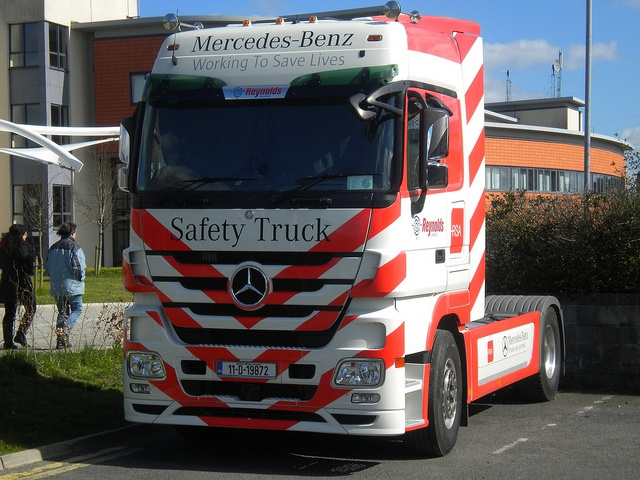Describe the objects in this image and their specific colors. I can see truck in gray, black, white, and maroon tones, people in gray, black, darkgray, and darkgreen tones, and people in gray, black, darkblue, and blue tones in this image. 